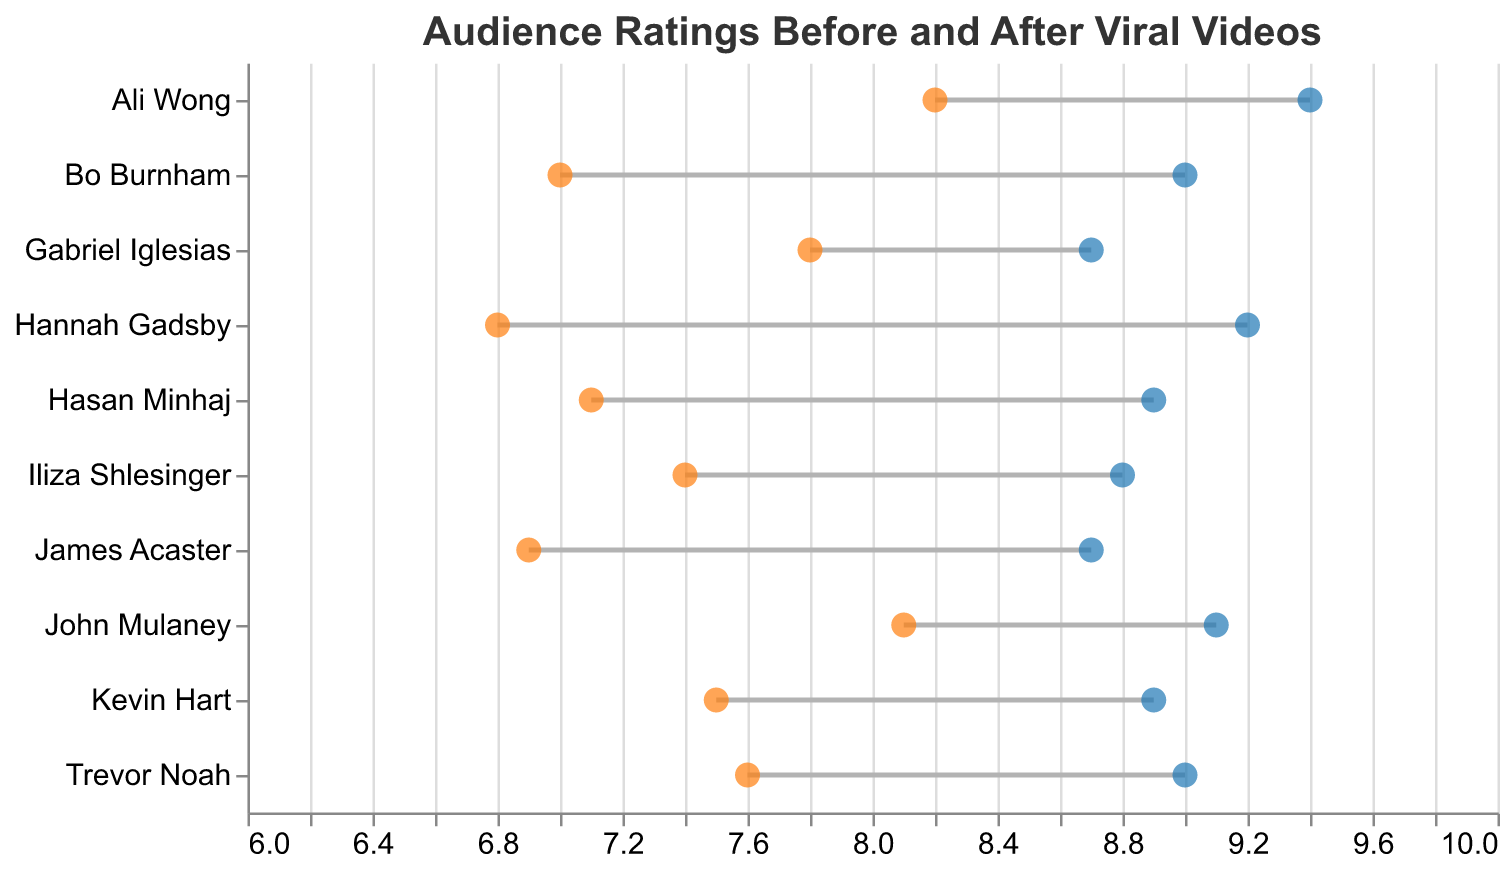What is the title of the plot? The title is displayed at the top of the plot. It reads "Audience Ratings Before and After Viral Videos".
Answer: Audience Ratings Before and After Viral Videos What does the x-axis represent? The x-axis is labeled "Audience Rating" and represents the audience ratings of the comedians before and after their viral videos.
Answer: Audience Rating Which comedian had the highest audience rating after their viral video? By looking at the endpoint of the blue points on the right, the highest value is for Ali Wong, which is 9.4.
Answer: Ali Wong Which comedian had the lowest audience rating before their viral video? By examining the orange points on the left, the lowest audience rating before the viral video is for Hannah Gadsby, which is 6.8.
Answer: Hannah Gadsby How much did Hannah Gadsby's rating improve after her viral video? The improvement can be calculated as the difference between the rating after the viral video (9.2) and before (6.8). So, 9.2 - 6.8 = 2.4.
Answer: 2.4 Which two comedians had the same rating after their viral videos and what is that rating? By observing the blue points, Bo Burnham and Trevor Noah both have a rating of 9.0.
Answer: Bo Burnham, Trevor Noah, 9.0 What is the average rating of all comedians before their viral videos? Add all the "Before Viral Video" ratings and divide by the number of comedians: (8.2 + 6.8 + 7.5 + 7.0 + 8.1 + 6.9 + 7.6 + 7.4 + 7.1 + 7.8) / 10 = 74.4 / 10 = 7.44
Answer: 7.44 How many comedians have an audience rating of 9.0 or higher after their viral videos? Count the number of blue points that are at or above 9.0. These are Ali Wong (9.4), Hannah Gadsby (9.2), Bo Burnham (9.0), John Mulaney (9.1), and Trevor Noah (9.0). There are 5 comedians.
Answer: 5 Which comedian had the smallest improvement in audience rating after their viral video? Calculate the difference between "After Viral Video" and "Before Viral Video" for each comedian. The smallest difference is for Gabriel Iglesias (8.7 - 7.8 = 0.9).
Answer: Gabriel Iglesias, 0.9 